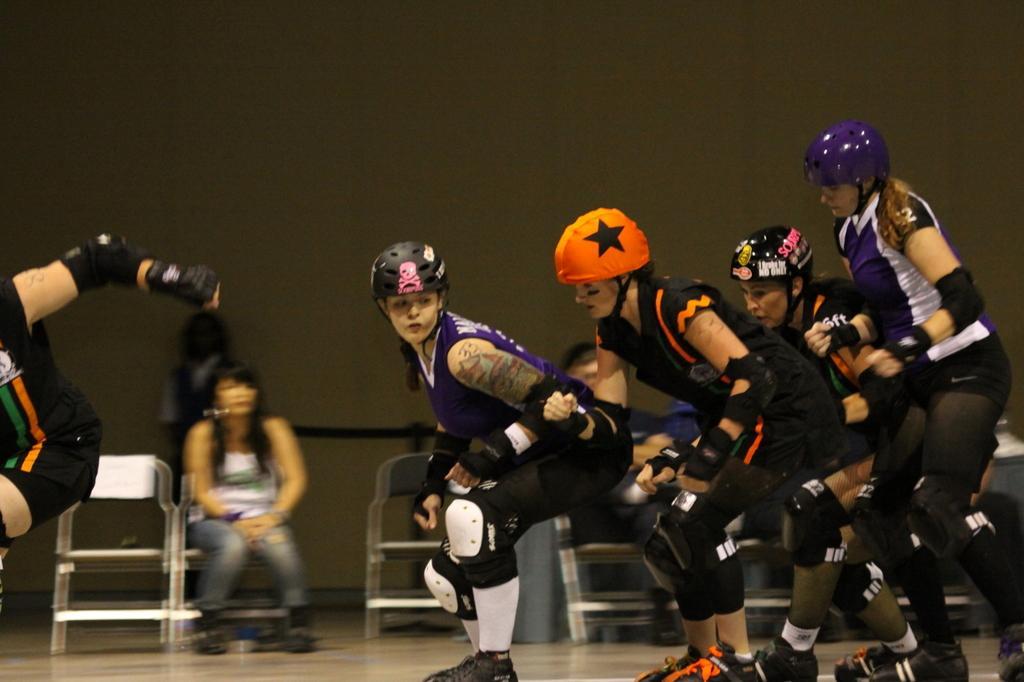Please provide a concise description of this image. In this image there are group of people who are wearing the helmets and jerseys and skating on the floor. They are wearing the gloves and pads. In the background is a woman sitting in the chair and there are few chairs beside her. There is a screen in the background. 